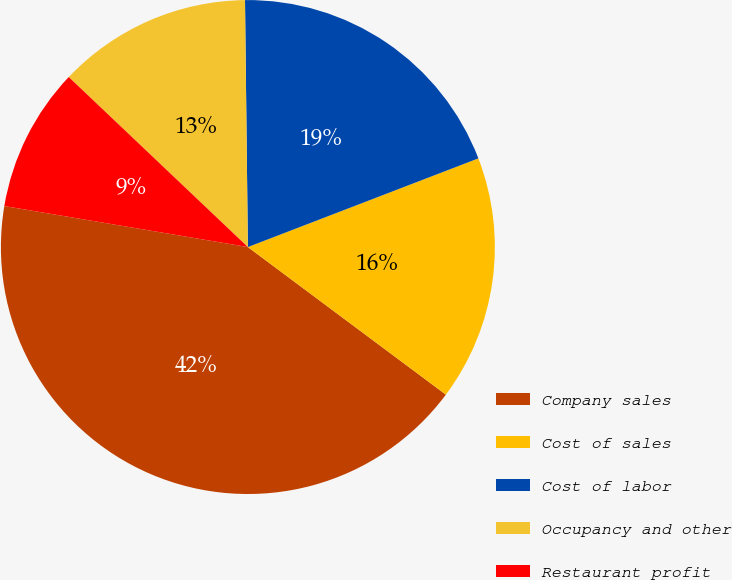Convert chart to OTSL. <chart><loc_0><loc_0><loc_500><loc_500><pie_chart><fcel>Company sales<fcel>Cost of sales<fcel>Cost of labor<fcel>Occupancy and other<fcel>Restaurant profit<nl><fcel>42.46%<fcel>16.04%<fcel>19.34%<fcel>12.73%<fcel>9.43%<nl></chart> 